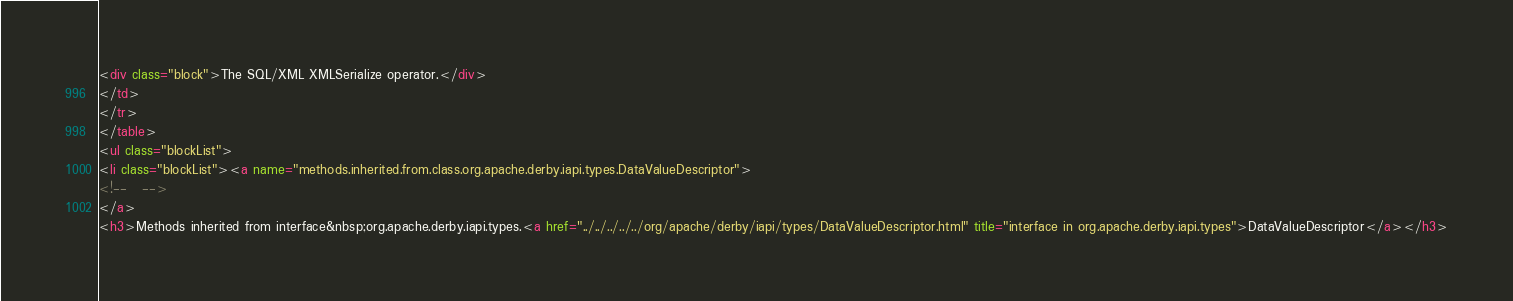Convert code to text. <code><loc_0><loc_0><loc_500><loc_500><_HTML_><div class="block">The SQL/XML XMLSerialize operator.</div>
</td>
</tr>
</table>
<ul class="blockList">
<li class="blockList"><a name="methods.inherited.from.class.org.apache.derby.iapi.types.DataValueDescriptor">
<!--   -->
</a>
<h3>Methods inherited from interface&nbsp;org.apache.derby.iapi.types.<a href="../../../../../org/apache/derby/iapi/types/DataValueDescriptor.html" title="interface in org.apache.derby.iapi.types">DataValueDescriptor</a></h3></code> 